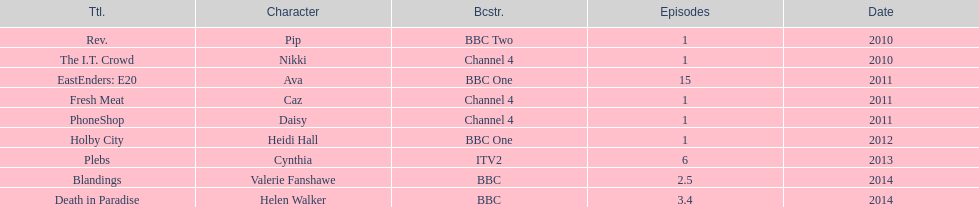How many titles have at least 5 episodes? 2. 